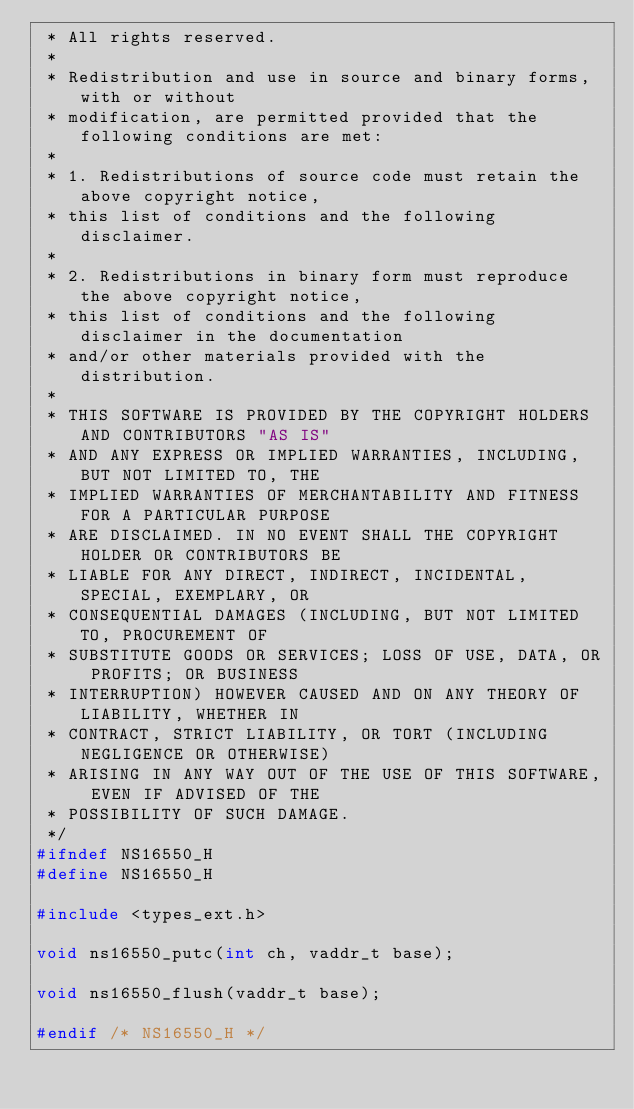Convert code to text. <code><loc_0><loc_0><loc_500><loc_500><_C_> * All rights reserved.
 *
 * Redistribution and use in source and binary forms, with or without
 * modification, are permitted provided that the following conditions are met:
 *
 * 1. Redistributions of source code must retain the above copyright notice,
 * this list of conditions and the following disclaimer.
 *
 * 2. Redistributions in binary form must reproduce the above copyright notice,
 * this list of conditions and the following disclaimer in the documentation
 * and/or other materials provided with the distribution.
 *
 * THIS SOFTWARE IS PROVIDED BY THE COPYRIGHT HOLDERS AND CONTRIBUTORS "AS IS"
 * AND ANY EXPRESS OR IMPLIED WARRANTIES, INCLUDING, BUT NOT LIMITED TO, THE
 * IMPLIED WARRANTIES OF MERCHANTABILITY AND FITNESS FOR A PARTICULAR PURPOSE
 * ARE DISCLAIMED. IN NO EVENT SHALL THE COPYRIGHT HOLDER OR CONTRIBUTORS BE
 * LIABLE FOR ANY DIRECT, INDIRECT, INCIDENTAL, SPECIAL, EXEMPLARY, OR
 * CONSEQUENTIAL DAMAGES (INCLUDING, BUT NOT LIMITED TO, PROCUREMENT OF
 * SUBSTITUTE GOODS OR SERVICES; LOSS OF USE, DATA, OR PROFITS; OR BUSINESS
 * INTERRUPTION) HOWEVER CAUSED AND ON ANY THEORY OF LIABILITY, WHETHER IN
 * CONTRACT, STRICT LIABILITY, OR TORT (INCLUDING NEGLIGENCE OR OTHERWISE)
 * ARISING IN ANY WAY OUT OF THE USE OF THIS SOFTWARE, EVEN IF ADVISED OF THE
 * POSSIBILITY OF SUCH DAMAGE.
 */
#ifndef NS16550_H
#define NS16550_H

#include <types_ext.h>

void ns16550_putc(int ch, vaddr_t base);

void ns16550_flush(vaddr_t base);

#endif /* NS16550_H */
</code> 